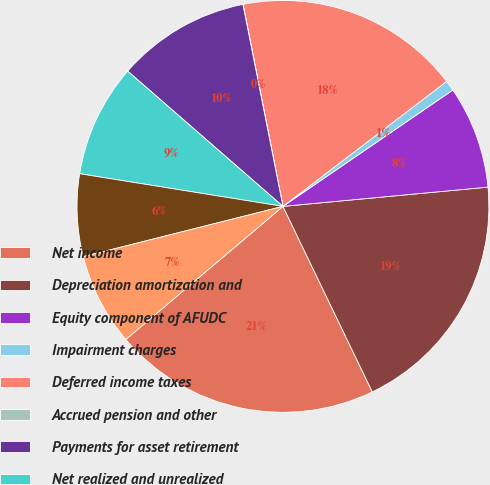<chart> <loc_0><loc_0><loc_500><loc_500><pie_chart><fcel>Net income<fcel>Depreciation amortization and<fcel>Equity component of AFUDC<fcel>Impairment charges<fcel>Deferred income taxes<fcel>Accrued pension and other<fcel>Payments for asset retirement<fcel>Net realized and unrealized<fcel>Receivables<fcel>Inventory<nl><fcel>20.96%<fcel>19.35%<fcel>8.07%<fcel>0.82%<fcel>17.73%<fcel>0.01%<fcel>10.48%<fcel>8.87%<fcel>6.46%<fcel>7.26%<nl></chart> 